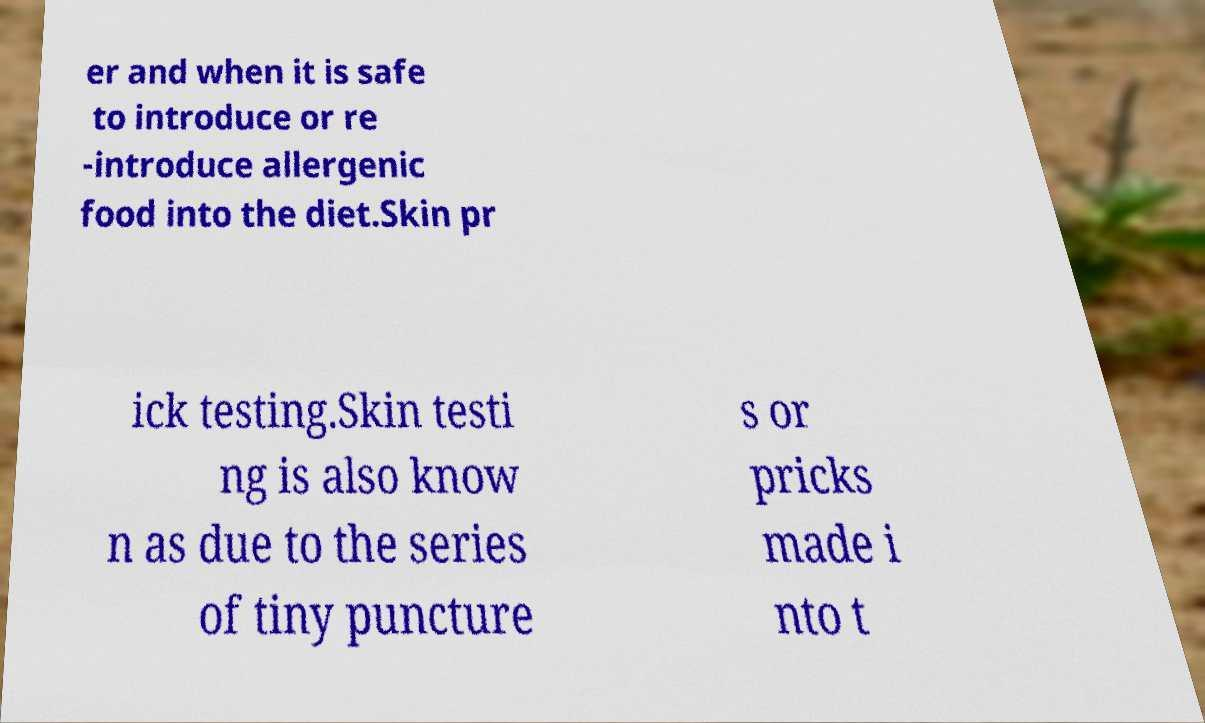There's text embedded in this image that I need extracted. Can you transcribe it verbatim? er and when it is safe to introduce or re -introduce allergenic food into the diet.Skin pr ick testing.Skin testi ng is also know n as due to the series of tiny puncture s or pricks made i nto t 